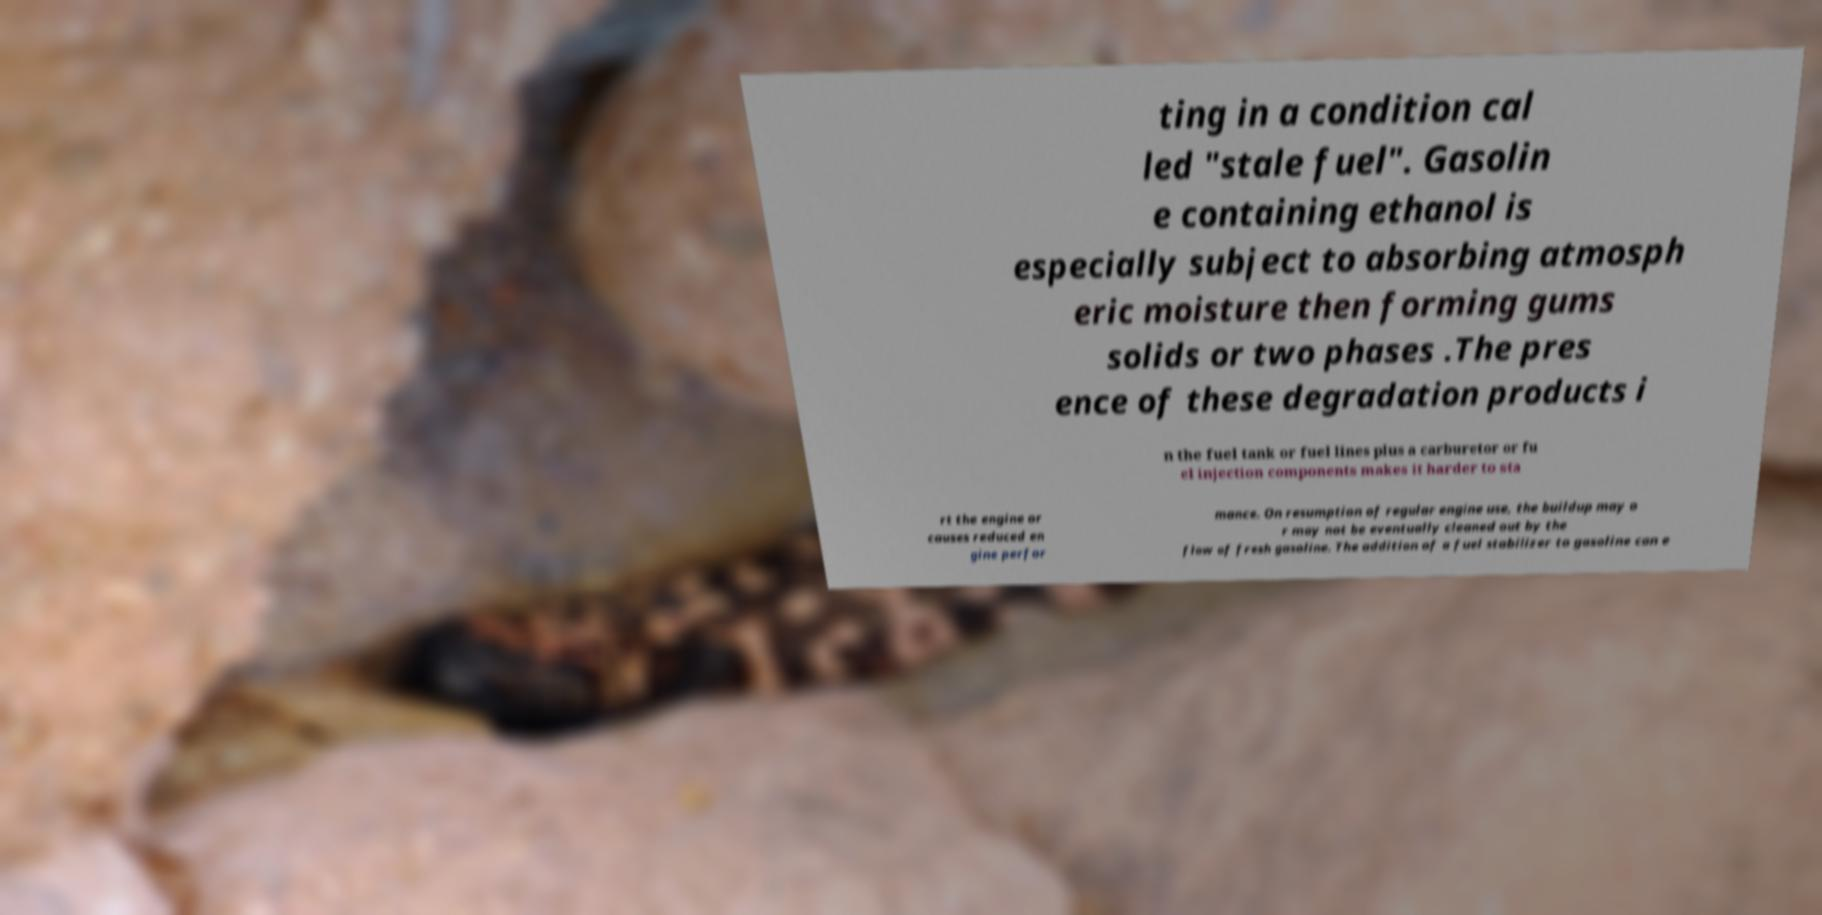Please identify and transcribe the text found in this image. ting in a condition cal led "stale fuel". Gasolin e containing ethanol is especially subject to absorbing atmosph eric moisture then forming gums solids or two phases .The pres ence of these degradation products i n the fuel tank or fuel lines plus a carburetor or fu el injection components makes it harder to sta rt the engine or causes reduced en gine perfor mance. On resumption of regular engine use, the buildup may o r may not be eventually cleaned out by the flow of fresh gasoline. The addition of a fuel stabilizer to gasoline can e 